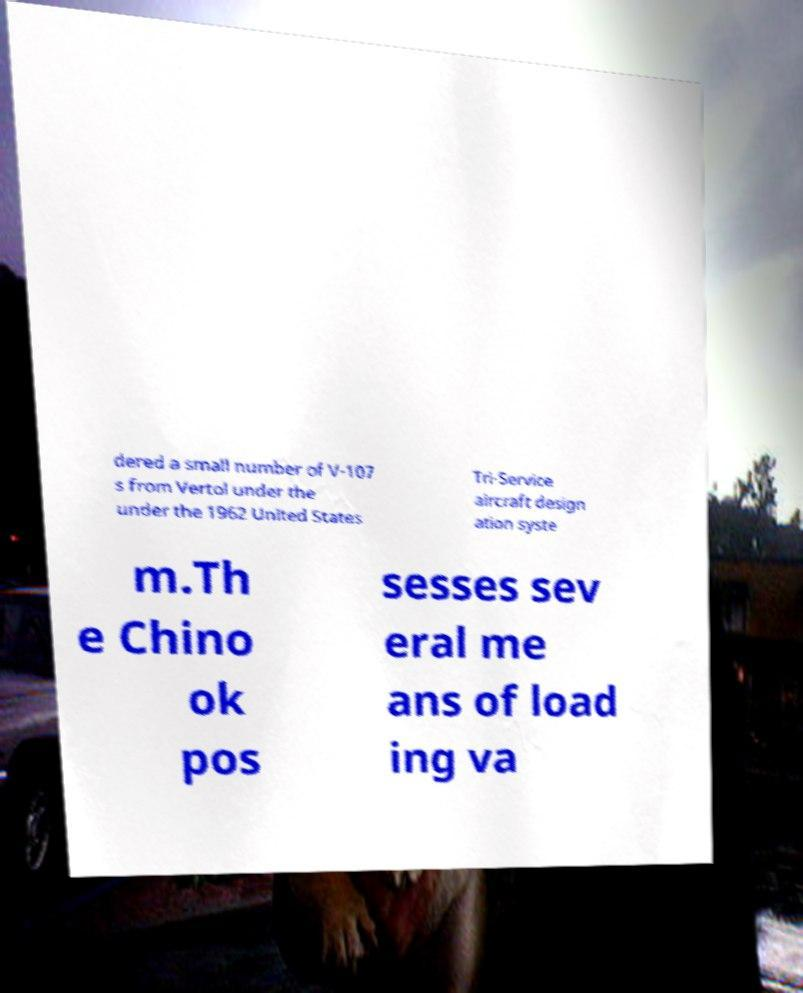I need the written content from this picture converted into text. Can you do that? dered a small number of V-107 s from Vertol under the under the 1962 United States Tri-Service aircraft design ation syste m.Th e Chino ok pos sesses sev eral me ans of load ing va 